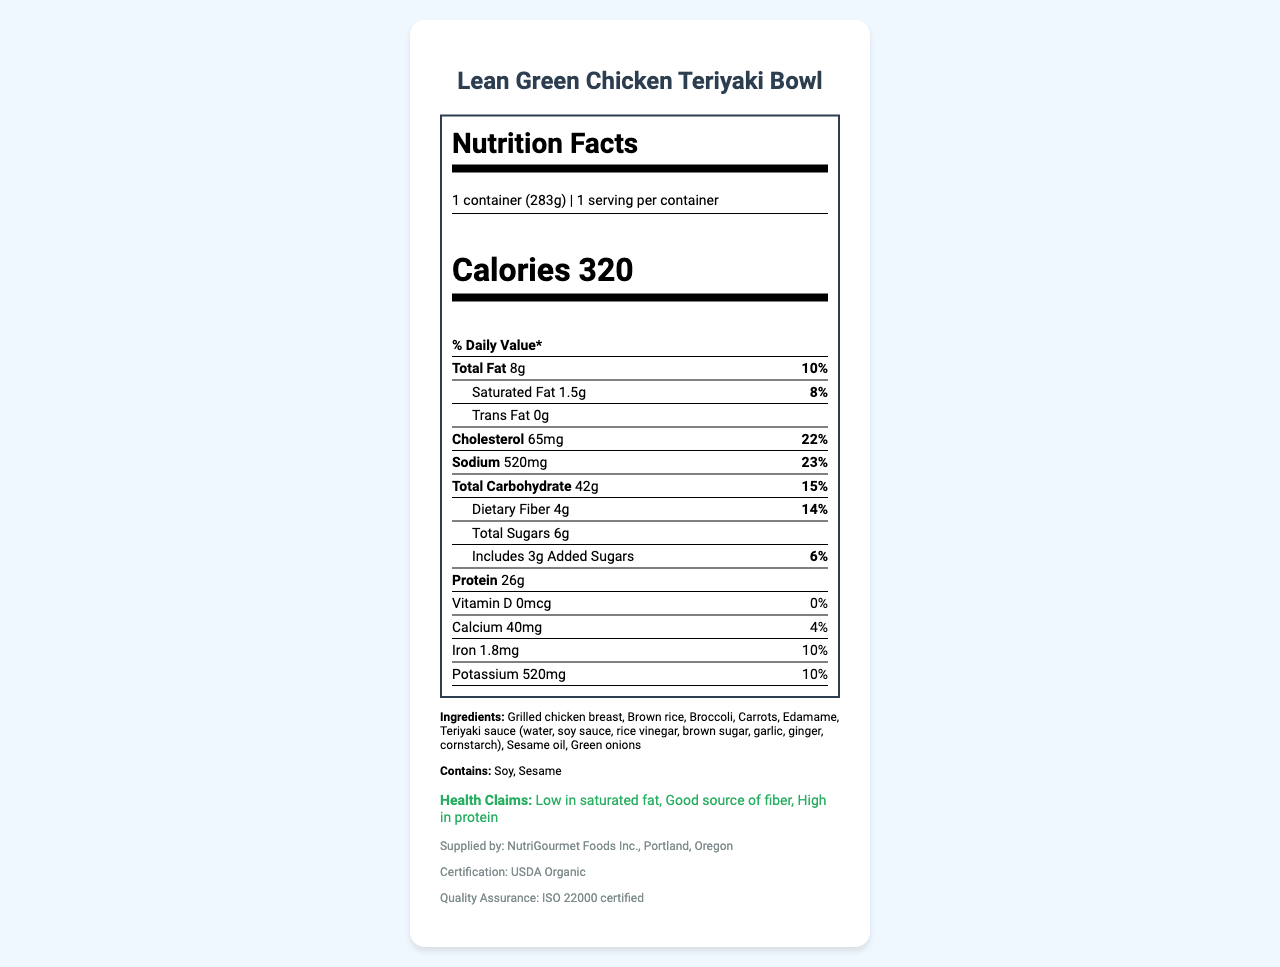what is the total fat content per serving? The total fat content per serving is directly stated as "Total Fat 8g" in the document.
Answer: 8g what percentage of the daily value does the sodium content represent? The daily value percentage for sodium is given as "23%" next to the sodium amount of 520mg.
Answer: 23% What is the serving size of the Lean Green Chicken Teriyaki Bowl? The serving size is stated clearly at the beginning of the nutrition facts: "1 container (283g)".
Answer: 1 container (283g) how much protein does the meal contain? The document specifies that the protein content is "26g".
Answer: 26g how much saturated fat is in this meal? The amount of saturated fat is listed as "1.5g" next to the daily value percentage of "8%".
Answer: 1.5g which nutrient has a daily value percentage of 10%? A. Total Fat B. Iron C. Potassium D. Calcium The nutrient label shows that Total Fat has a daily value percentage of "10%" among the given options.
Answer: A. Total Fat what is the profit margin for this product? A. 25% B. 50% C. 54% D. 60% The profit margin is stated in the cost efficiency section as "54%".
Answer: C. 54% does this product contain any allergens? The ingredients section lists "Soy" and "Sesame" under the allergens sub-section.
Answer: Yes is this meal low in saturated fat? One of the health claims specifically states "Low in saturated fat".
Answer: Yes provide a summary of the document. The document provides detailed food nutrition and supplementary information for a health-conscious product, highlighting its low saturated fat content, rich protein, and competitive advantages in sodium and fat content relative to competitors, aiming at health-conscious professionals.
Answer: The document is a comprehensive Nutrition Facts Label for Lean Green Chicken Teriyaki Bowl, revealing the nutritional information per serving, key ingredients, allergen details, several health claims, supplier information, cost-efficiency data, packaging details, and competitive analysis. The meal is low in saturated fat, rich in protein, and emphasizes health conscious aspects. how many milligrams of cholesterol are in this meal? The cholesterol content is clearly listed as "65mg".
Answer: 65mg can the exact number of employees at NutriGourmet Foods Inc. be determined from this document? The document does not provide any information about the number of employees at NutriGourmet Foods Inc.
Answer: Cannot be determined 